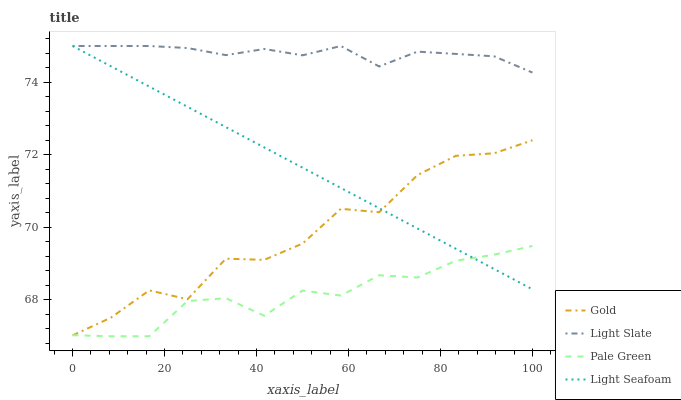Does Pale Green have the minimum area under the curve?
Answer yes or no. Yes. Does Light Slate have the maximum area under the curve?
Answer yes or no. Yes. Does Light Seafoam have the minimum area under the curve?
Answer yes or no. No. Does Light Seafoam have the maximum area under the curve?
Answer yes or no. No. Is Light Seafoam the smoothest?
Answer yes or no. Yes. Is Gold the roughest?
Answer yes or no. Yes. Is Pale Green the smoothest?
Answer yes or no. No. Is Pale Green the roughest?
Answer yes or no. No. Does Pale Green have the lowest value?
Answer yes or no. Yes. Does Light Seafoam have the lowest value?
Answer yes or no. No. Does Light Seafoam have the highest value?
Answer yes or no. Yes. Does Pale Green have the highest value?
Answer yes or no. No. Is Gold less than Light Slate?
Answer yes or no. Yes. Is Light Slate greater than Gold?
Answer yes or no. Yes. Does Light Seafoam intersect Gold?
Answer yes or no. Yes. Is Light Seafoam less than Gold?
Answer yes or no. No. Is Light Seafoam greater than Gold?
Answer yes or no. No. Does Gold intersect Light Slate?
Answer yes or no. No. 